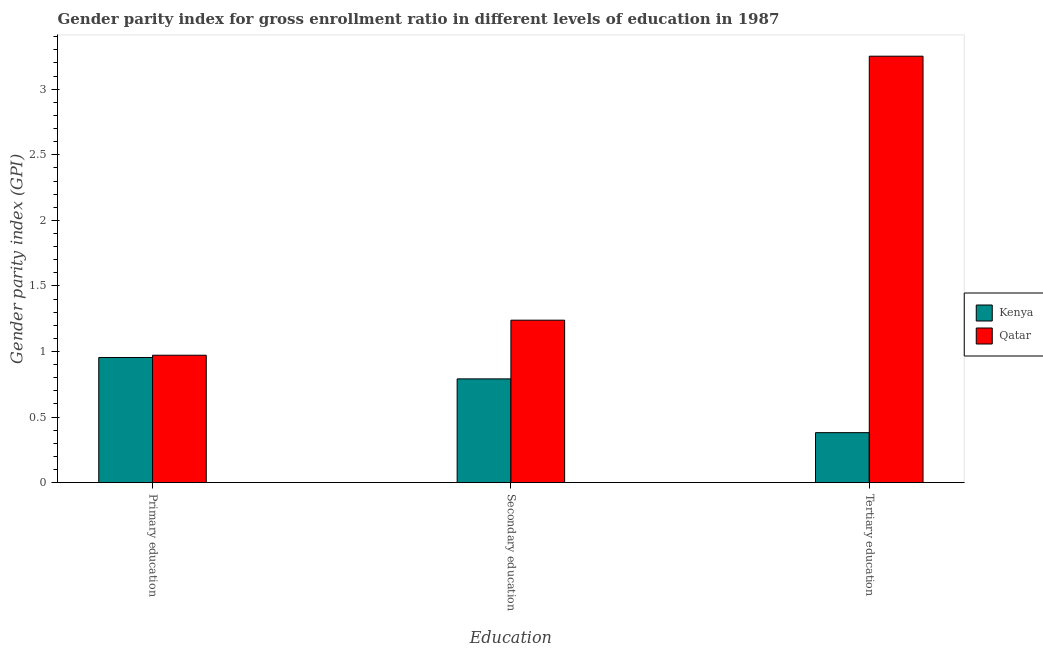How many different coloured bars are there?
Offer a very short reply. 2. Are the number of bars per tick equal to the number of legend labels?
Ensure brevity in your answer.  Yes. What is the gender parity index in primary education in Kenya?
Provide a short and direct response. 0.95. Across all countries, what is the maximum gender parity index in tertiary education?
Your answer should be compact. 3.25. Across all countries, what is the minimum gender parity index in primary education?
Give a very brief answer. 0.95. In which country was the gender parity index in tertiary education maximum?
Make the answer very short. Qatar. In which country was the gender parity index in tertiary education minimum?
Make the answer very short. Kenya. What is the total gender parity index in primary education in the graph?
Offer a terse response. 1.93. What is the difference between the gender parity index in tertiary education in Kenya and that in Qatar?
Your answer should be compact. -2.87. What is the difference between the gender parity index in tertiary education in Qatar and the gender parity index in secondary education in Kenya?
Provide a succinct answer. 2.46. What is the average gender parity index in secondary education per country?
Offer a terse response. 1.01. What is the difference between the gender parity index in primary education and gender parity index in tertiary education in Qatar?
Give a very brief answer. -2.28. In how many countries, is the gender parity index in primary education greater than 1.7 ?
Your response must be concise. 0. What is the ratio of the gender parity index in secondary education in Qatar to that in Kenya?
Your answer should be compact. 1.57. Is the difference between the gender parity index in primary education in Qatar and Kenya greater than the difference between the gender parity index in tertiary education in Qatar and Kenya?
Make the answer very short. No. What is the difference between the highest and the second highest gender parity index in tertiary education?
Your response must be concise. 2.87. What is the difference between the highest and the lowest gender parity index in secondary education?
Offer a very short reply. 0.45. Is the sum of the gender parity index in tertiary education in Qatar and Kenya greater than the maximum gender parity index in secondary education across all countries?
Provide a succinct answer. Yes. What does the 1st bar from the left in Primary education represents?
Offer a very short reply. Kenya. What does the 2nd bar from the right in Secondary education represents?
Offer a very short reply. Kenya. How many bars are there?
Offer a terse response. 6. Are all the bars in the graph horizontal?
Make the answer very short. No. How many countries are there in the graph?
Offer a very short reply. 2. What is the difference between two consecutive major ticks on the Y-axis?
Offer a very short reply. 0.5. Does the graph contain any zero values?
Offer a very short reply. No. Does the graph contain grids?
Provide a succinct answer. No. Where does the legend appear in the graph?
Provide a short and direct response. Center right. How many legend labels are there?
Provide a short and direct response. 2. What is the title of the graph?
Ensure brevity in your answer.  Gender parity index for gross enrollment ratio in different levels of education in 1987. What is the label or title of the X-axis?
Keep it short and to the point. Education. What is the label or title of the Y-axis?
Give a very brief answer. Gender parity index (GPI). What is the Gender parity index (GPI) in Kenya in Primary education?
Ensure brevity in your answer.  0.95. What is the Gender parity index (GPI) in Qatar in Primary education?
Your answer should be very brief. 0.97. What is the Gender parity index (GPI) of Kenya in Secondary education?
Offer a terse response. 0.79. What is the Gender parity index (GPI) in Qatar in Secondary education?
Provide a short and direct response. 1.24. What is the Gender parity index (GPI) of Kenya in Tertiary education?
Keep it short and to the point. 0.38. What is the Gender parity index (GPI) of Qatar in Tertiary education?
Provide a succinct answer. 3.25. Across all Education, what is the maximum Gender parity index (GPI) in Kenya?
Your answer should be compact. 0.95. Across all Education, what is the maximum Gender parity index (GPI) in Qatar?
Offer a very short reply. 3.25. Across all Education, what is the minimum Gender parity index (GPI) in Kenya?
Give a very brief answer. 0.38. Across all Education, what is the minimum Gender parity index (GPI) in Qatar?
Make the answer very short. 0.97. What is the total Gender parity index (GPI) of Kenya in the graph?
Your answer should be compact. 2.13. What is the total Gender parity index (GPI) of Qatar in the graph?
Ensure brevity in your answer.  5.46. What is the difference between the Gender parity index (GPI) of Kenya in Primary education and that in Secondary education?
Provide a short and direct response. 0.16. What is the difference between the Gender parity index (GPI) of Qatar in Primary education and that in Secondary education?
Offer a terse response. -0.27. What is the difference between the Gender parity index (GPI) of Kenya in Primary education and that in Tertiary education?
Make the answer very short. 0.57. What is the difference between the Gender parity index (GPI) in Qatar in Primary education and that in Tertiary education?
Offer a terse response. -2.28. What is the difference between the Gender parity index (GPI) in Kenya in Secondary education and that in Tertiary education?
Your answer should be very brief. 0.41. What is the difference between the Gender parity index (GPI) in Qatar in Secondary education and that in Tertiary education?
Your answer should be compact. -2.01. What is the difference between the Gender parity index (GPI) of Kenya in Primary education and the Gender parity index (GPI) of Qatar in Secondary education?
Give a very brief answer. -0.28. What is the difference between the Gender parity index (GPI) in Kenya in Primary education and the Gender parity index (GPI) in Qatar in Tertiary education?
Provide a succinct answer. -2.3. What is the difference between the Gender parity index (GPI) in Kenya in Secondary education and the Gender parity index (GPI) in Qatar in Tertiary education?
Keep it short and to the point. -2.46. What is the average Gender parity index (GPI) of Kenya per Education?
Give a very brief answer. 0.71. What is the average Gender parity index (GPI) of Qatar per Education?
Your response must be concise. 1.82. What is the difference between the Gender parity index (GPI) in Kenya and Gender parity index (GPI) in Qatar in Primary education?
Give a very brief answer. -0.02. What is the difference between the Gender parity index (GPI) in Kenya and Gender parity index (GPI) in Qatar in Secondary education?
Your response must be concise. -0.45. What is the difference between the Gender parity index (GPI) in Kenya and Gender parity index (GPI) in Qatar in Tertiary education?
Offer a terse response. -2.87. What is the ratio of the Gender parity index (GPI) of Kenya in Primary education to that in Secondary education?
Keep it short and to the point. 1.21. What is the ratio of the Gender parity index (GPI) of Qatar in Primary education to that in Secondary education?
Ensure brevity in your answer.  0.78. What is the ratio of the Gender parity index (GPI) of Kenya in Primary education to that in Tertiary education?
Your answer should be very brief. 2.5. What is the ratio of the Gender parity index (GPI) of Qatar in Primary education to that in Tertiary education?
Your answer should be very brief. 0.3. What is the ratio of the Gender parity index (GPI) in Kenya in Secondary education to that in Tertiary education?
Your answer should be compact. 2.08. What is the ratio of the Gender parity index (GPI) in Qatar in Secondary education to that in Tertiary education?
Your answer should be compact. 0.38. What is the difference between the highest and the second highest Gender parity index (GPI) of Kenya?
Your answer should be compact. 0.16. What is the difference between the highest and the second highest Gender parity index (GPI) in Qatar?
Ensure brevity in your answer.  2.01. What is the difference between the highest and the lowest Gender parity index (GPI) of Kenya?
Your response must be concise. 0.57. What is the difference between the highest and the lowest Gender parity index (GPI) in Qatar?
Offer a very short reply. 2.28. 